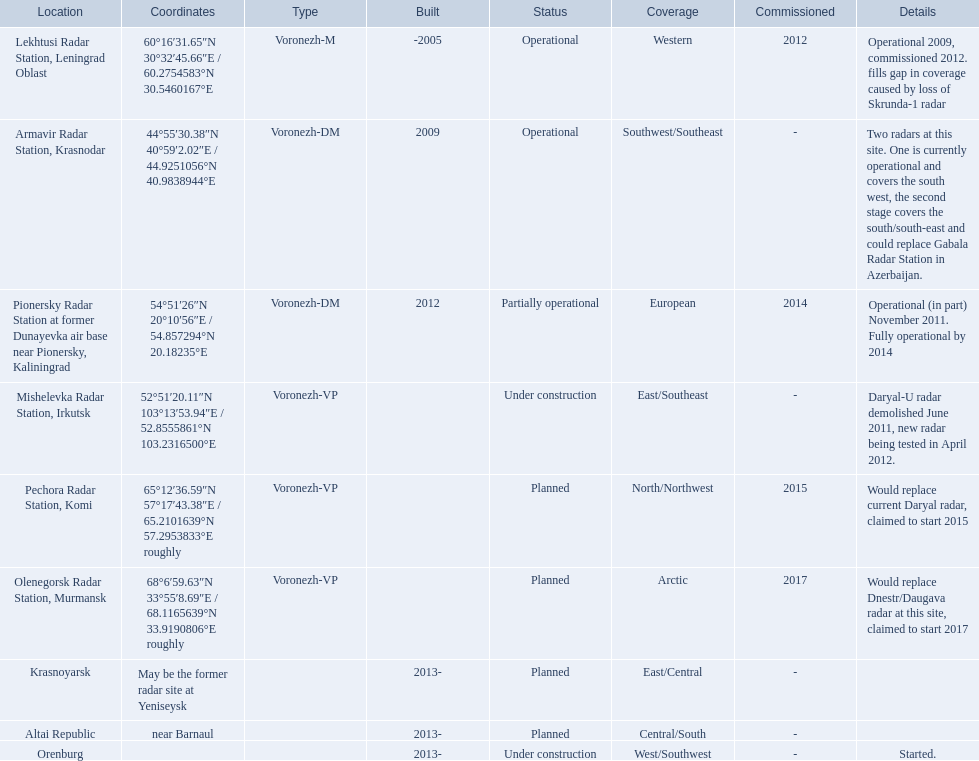What are all of the locations? Lekhtusi Radar Station, Leningrad Oblast, Armavir Radar Station, Krasnodar, Pionersky Radar Station at former Dunayevka air base near Pionersky, Kaliningrad, Mishelevka Radar Station, Irkutsk, Pechora Radar Station, Komi, Olenegorsk Radar Station, Murmansk, Krasnoyarsk, Altai Republic, Orenburg. And which location's coordinates are 60deg16'31.65''n 30deg32'45.66''e / 60.2754583degn 30.5460167dege? Lekhtusi Radar Station, Leningrad Oblast. 